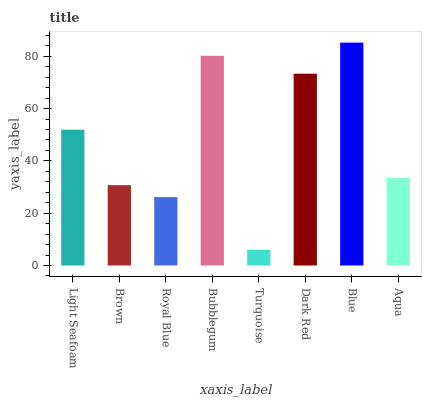Is Turquoise the minimum?
Answer yes or no. Yes. Is Blue the maximum?
Answer yes or no. Yes. Is Brown the minimum?
Answer yes or no. No. Is Brown the maximum?
Answer yes or no. No. Is Light Seafoam greater than Brown?
Answer yes or no. Yes. Is Brown less than Light Seafoam?
Answer yes or no. Yes. Is Brown greater than Light Seafoam?
Answer yes or no. No. Is Light Seafoam less than Brown?
Answer yes or no. No. Is Light Seafoam the high median?
Answer yes or no. Yes. Is Aqua the low median?
Answer yes or no. Yes. Is Aqua the high median?
Answer yes or no. No. Is Blue the low median?
Answer yes or no. No. 